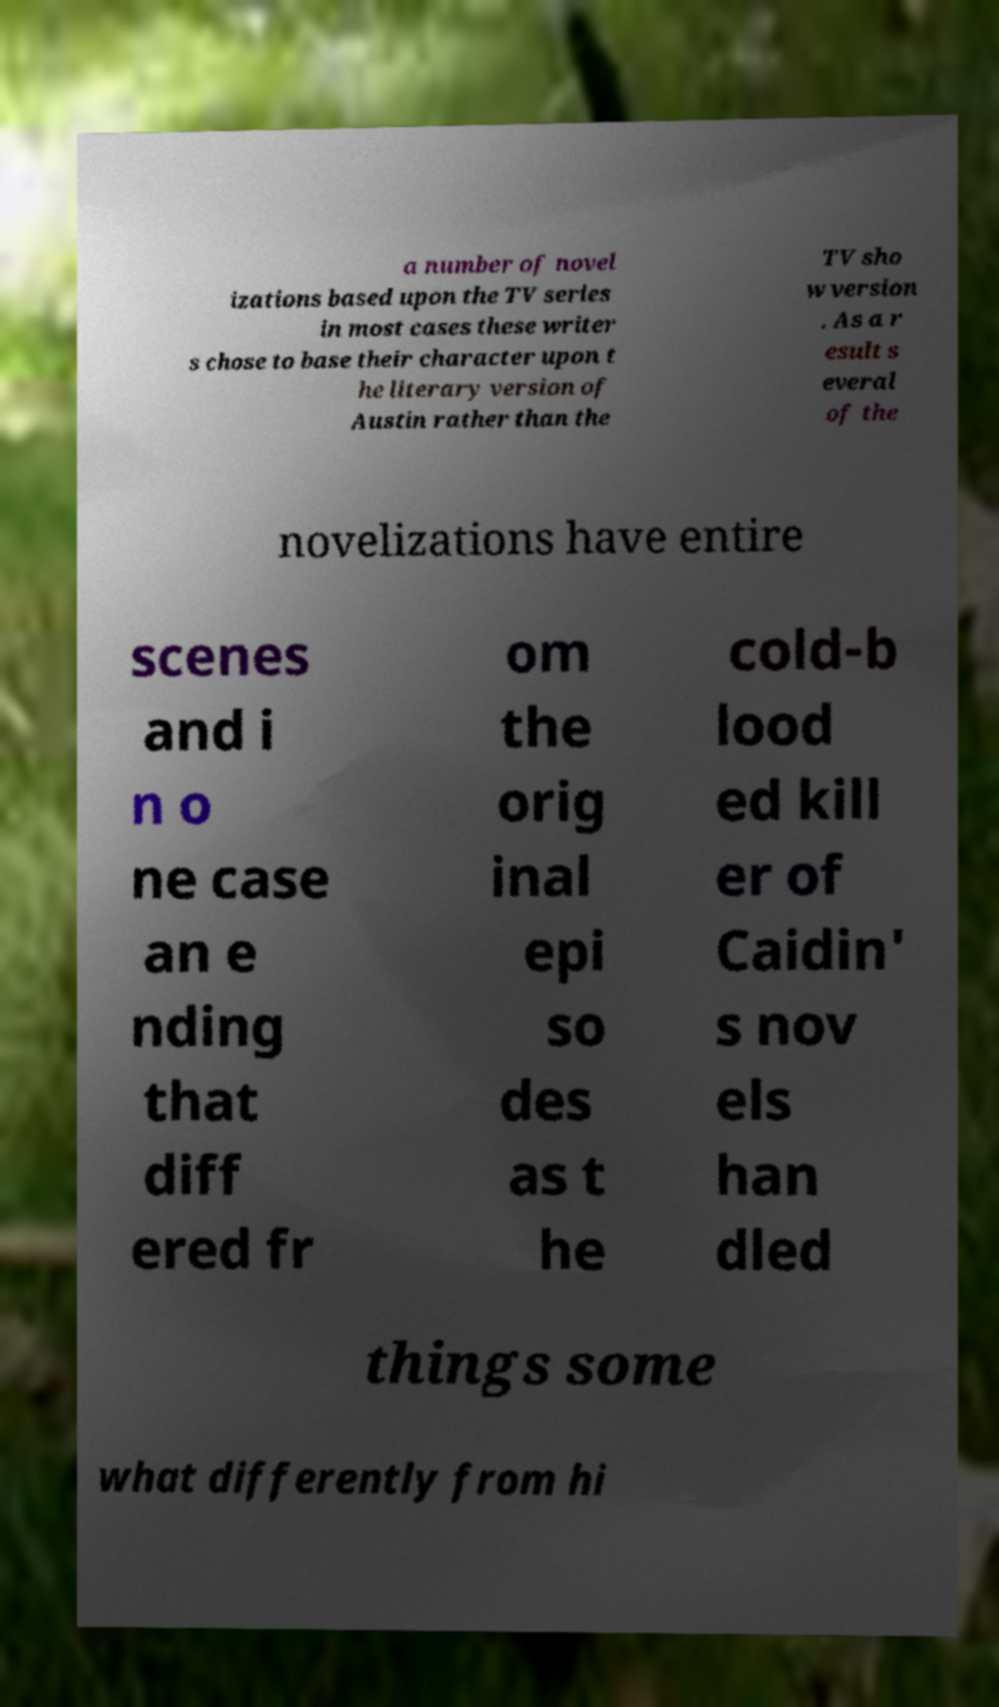Please read and relay the text visible in this image. What does it say? a number of novel izations based upon the TV series in most cases these writer s chose to base their character upon t he literary version of Austin rather than the TV sho w version . As a r esult s everal of the novelizations have entire scenes and i n o ne case an e nding that diff ered fr om the orig inal epi so des as t he cold-b lood ed kill er of Caidin' s nov els han dled things some what differently from hi 